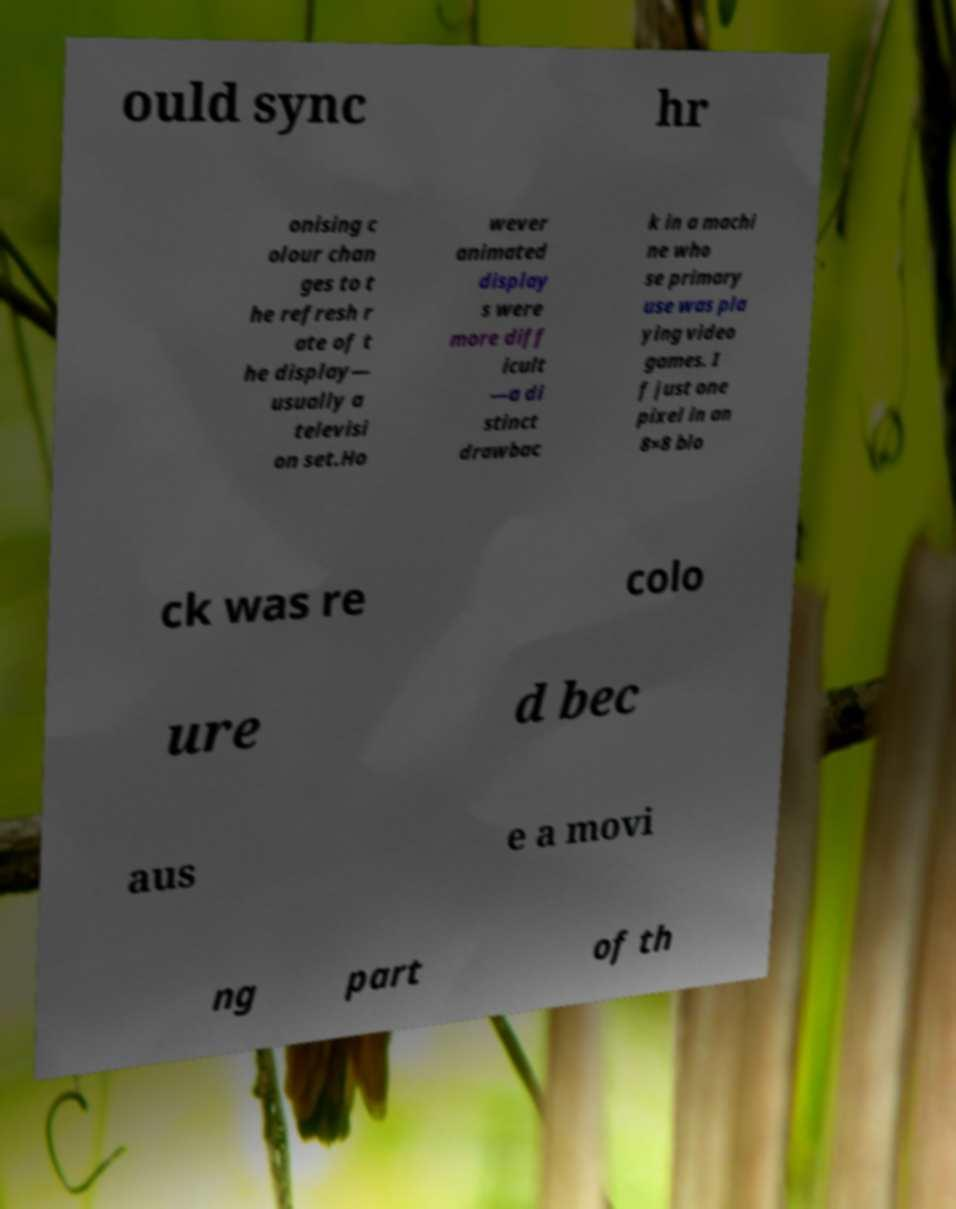For documentation purposes, I need the text within this image transcribed. Could you provide that? ould sync hr onising c olour chan ges to t he refresh r ate of t he display— usually a televisi on set.Ho wever animated display s were more diff icult —a di stinct drawbac k in a machi ne who se primary use was pla ying video games. I f just one pixel in an 8×8 blo ck was re colo ure d bec aus e a movi ng part of th 